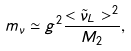<formula> <loc_0><loc_0><loc_500><loc_500>m _ { \nu } \simeq g ^ { 2 } \frac { < \tilde { \nu } _ { L } > ^ { 2 } } { M _ { 2 } } ,</formula> 